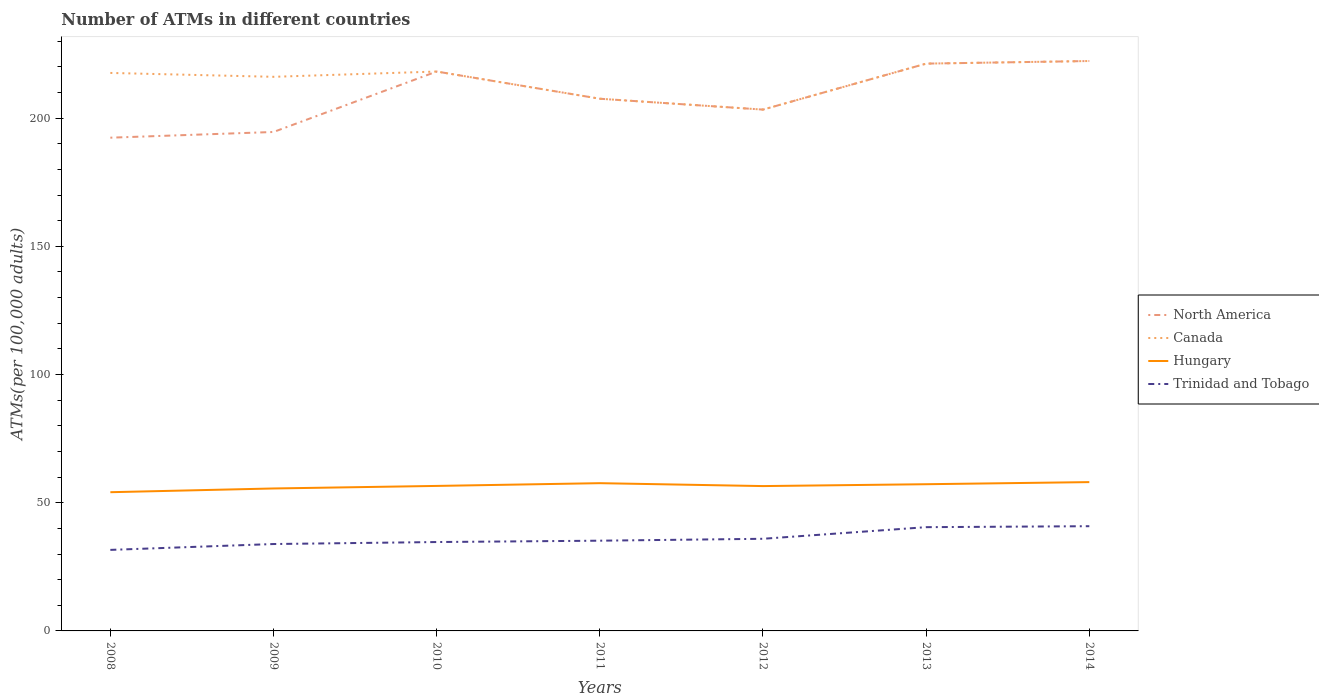How many different coloured lines are there?
Offer a terse response. 4. Across all years, what is the maximum number of ATMs in Trinidad and Tobago?
Make the answer very short. 31.6. What is the total number of ATMs in Hungary in the graph?
Your answer should be compact. 0.06. What is the difference between the highest and the second highest number of ATMs in Trinidad and Tobago?
Your answer should be very brief. 9.24. How many years are there in the graph?
Provide a succinct answer. 7. Does the graph contain any zero values?
Provide a succinct answer. No. Does the graph contain grids?
Give a very brief answer. No. How many legend labels are there?
Your answer should be very brief. 4. How are the legend labels stacked?
Your response must be concise. Vertical. What is the title of the graph?
Offer a terse response. Number of ATMs in different countries. What is the label or title of the Y-axis?
Your answer should be very brief. ATMs(per 100,0 adults). What is the ATMs(per 100,000 adults) in North America in 2008?
Provide a short and direct response. 192.37. What is the ATMs(per 100,000 adults) of Canada in 2008?
Ensure brevity in your answer.  217.63. What is the ATMs(per 100,000 adults) in Hungary in 2008?
Keep it short and to the point. 54.1. What is the ATMs(per 100,000 adults) in Trinidad and Tobago in 2008?
Make the answer very short. 31.6. What is the ATMs(per 100,000 adults) in North America in 2009?
Your response must be concise. 194.6. What is the ATMs(per 100,000 adults) of Canada in 2009?
Ensure brevity in your answer.  216.11. What is the ATMs(per 100,000 adults) of Hungary in 2009?
Give a very brief answer. 55.56. What is the ATMs(per 100,000 adults) in Trinidad and Tobago in 2009?
Provide a succinct answer. 33.89. What is the ATMs(per 100,000 adults) of North America in 2010?
Keep it short and to the point. 218.18. What is the ATMs(per 100,000 adults) of Canada in 2010?
Offer a terse response. 218.18. What is the ATMs(per 100,000 adults) of Hungary in 2010?
Give a very brief answer. 56.55. What is the ATMs(per 100,000 adults) in Trinidad and Tobago in 2010?
Offer a terse response. 34.67. What is the ATMs(per 100,000 adults) in North America in 2011?
Offer a very short reply. 207.56. What is the ATMs(per 100,000 adults) in Canada in 2011?
Ensure brevity in your answer.  207.56. What is the ATMs(per 100,000 adults) of Hungary in 2011?
Offer a terse response. 57.63. What is the ATMs(per 100,000 adults) of Trinidad and Tobago in 2011?
Offer a very short reply. 35.19. What is the ATMs(per 100,000 adults) in North America in 2012?
Provide a short and direct response. 203.33. What is the ATMs(per 100,000 adults) in Canada in 2012?
Your answer should be very brief. 203.33. What is the ATMs(per 100,000 adults) in Hungary in 2012?
Ensure brevity in your answer.  56.49. What is the ATMs(per 100,000 adults) of Trinidad and Tobago in 2012?
Your answer should be compact. 35.94. What is the ATMs(per 100,000 adults) in North America in 2013?
Provide a succinct answer. 221.26. What is the ATMs(per 100,000 adults) of Canada in 2013?
Offer a terse response. 221.26. What is the ATMs(per 100,000 adults) in Hungary in 2013?
Ensure brevity in your answer.  57.22. What is the ATMs(per 100,000 adults) of Trinidad and Tobago in 2013?
Your answer should be compact. 40.47. What is the ATMs(per 100,000 adults) of North America in 2014?
Provide a succinct answer. 222.27. What is the ATMs(per 100,000 adults) in Canada in 2014?
Give a very brief answer. 222.27. What is the ATMs(per 100,000 adults) in Hungary in 2014?
Your response must be concise. 58.04. What is the ATMs(per 100,000 adults) in Trinidad and Tobago in 2014?
Your answer should be compact. 40.84. Across all years, what is the maximum ATMs(per 100,000 adults) of North America?
Your response must be concise. 222.27. Across all years, what is the maximum ATMs(per 100,000 adults) of Canada?
Make the answer very short. 222.27. Across all years, what is the maximum ATMs(per 100,000 adults) of Hungary?
Your answer should be compact. 58.04. Across all years, what is the maximum ATMs(per 100,000 adults) in Trinidad and Tobago?
Provide a succinct answer. 40.84. Across all years, what is the minimum ATMs(per 100,000 adults) of North America?
Your response must be concise. 192.37. Across all years, what is the minimum ATMs(per 100,000 adults) of Canada?
Provide a succinct answer. 203.33. Across all years, what is the minimum ATMs(per 100,000 adults) in Hungary?
Provide a succinct answer. 54.1. Across all years, what is the minimum ATMs(per 100,000 adults) of Trinidad and Tobago?
Offer a terse response. 31.6. What is the total ATMs(per 100,000 adults) in North America in the graph?
Your answer should be compact. 1459.57. What is the total ATMs(per 100,000 adults) in Canada in the graph?
Ensure brevity in your answer.  1506.34. What is the total ATMs(per 100,000 adults) in Hungary in the graph?
Make the answer very short. 395.59. What is the total ATMs(per 100,000 adults) in Trinidad and Tobago in the graph?
Provide a short and direct response. 252.6. What is the difference between the ATMs(per 100,000 adults) of North America in 2008 and that in 2009?
Make the answer very short. -2.23. What is the difference between the ATMs(per 100,000 adults) in Canada in 2008 and that in 2009?
Ensure brevity in your answer.  1.51. What is the difference between the ATMs(per 100,000 adults) of Hungary in 2008 and that in 2009?
Keep it short and to the point. -1.46. What is the difference between the ATMs(per 100,000 adults) of Trinidad and Tobago in 2008 and that in 2009?
Your response must be concise. -2.29. What is the difference between the ATMs(per 100,000 adults) in North America in 2008 and that in 2010?
Your response must be concise. -25.8. What is the difference between the ATMs(per 100,000 adults) in Canada in 2008 and that in 2010?
Give a very brief answer. -0.55. What is the difference between the ATMs(per 100,000 adults) in Hungary in 2008 and that in 2010?
Ensure brevity in your answer.  -2.45. What is the difference between the ATMs(per 100,000 adults) of Trinidad and Tobago in 2008 and that in 2010?
Your response must be concise. -3.06. What is the difference between the ATMs(per 100,000 adults) in North America in 2008 and that in 2011?
Ensure brevity in your answer.  -15.19. What is the difference between the ATMs(per 100,000 adults) of Canada in 2008 and that in 2011?
Your response must be concise. 10.06. What is the difference between the ATMs(per 100,000 adults) in Hungary in 2008 and that in 2011?
Keep it short and to the point. -3.52. What is the difference between the ATMs(per 100,000 adults) in Trinidad and Tobago in 2008 and that in 2011?
Give a very brief answer. -3.59. What is the difference between the ATMs(per 100,000 adults) in North America in 2008 and that in 2012?
Provide a short and direct response. -10.95. What is the difference between the ATMs(per 100,000 adults) of Canada in 2008 and that in 2012?
Your answer should be very brief. 14.3. What is the difference between the ATMs(per 100,000 adults) in Hungary in 2008 and that in 2012?
Keep it short and to the point. -2.39. What is the difference between the ATMs(per 100,000 adults) of Trinidad and Tobago in 2008 and that in 2012?
Provide a succinct answer. -4.33. What is the difference between the ATMs(per 100,000 adults) in North America in 2008 and that in 2013?
Ensure brevity in your answer.  -28.89. What is the difference between the ATMs(per 100,000 adults) in Canada in 2008 and that in 2013?
Your answer should be very brief. -3.63. What is the difference between the ATMs(per 100,000 adults) of Hungary in 2008 and that in 2013?
Your response must be concise. -3.11. What is the difference between the ATMs(per 100,000 adults) in Trinidad and Tobago in 2008 and that in 2013?
Offer a terse response. -8.86. What is the difference between the ATMs(per 100,000 adults) of North America in 2008 and that in 2014?
Offer a terse response. -29.9. What is the difference between the ATMs(per 100,000 adults) in Canada in 2008 and that in 2014?
Keep it short and to the point. -4.65. What is the difference between the ATMs(per 100,000 adults) in Hungary in 2008 and that in 2014?
Give a very brief answer. -3.93. What is the difference between the ATMs(per 100,000 adults) in Trinidad and Tobago in 2008 and that in 2014?
Keep it short and to the point. -9.24. What is the difference between the ATMs(per 100,000 adults) in North America in 2009 and that in 2010?
Your response must be concise. -23.58. What is the difference between the ATMs(per 100,000 adults) of Canada in 2009 and that in 2010?
Your answer should be very brief. -2.06. What is the difference between the ATMs(per 100,000 adults) of Hungary in 2009 and that in 2010?
Give a very brief answer. -0.99. What is the difference between the ATMs(per 100,000 adults) in Trinidad and Tobago in 2009 and that in 2010?
Keep it short and to the point. -0.78. What is the difference between the ATMs(per 100,000 adults) in North America in 2009 and that in 2011?
Your response must be concise. -12.96. What is the difference between the ATMs(per 100,000 adults) in Canada in 2009 and that in 2011?
Provide a succinct answer. 8.55. What is the difference between the ATMs(per 100,000 adults) in Hungary in 2009 and that in 2011?
Give a very brief answer. -2.07. What is the difference between the ATMs(per 100,000 adults) of Trinidad and Tobago in 2009 and that in 2011?
Ensure brevity in your answer.  -1.3. What is the difference between the ATMs(per 100,000 adults) in North America in 2009 and that in 2012?
Provide a succinct answer. -8.73. What is the difference between the ATMs(per 100,000 adults) in Canada in 2009 and that in 2012?
Your response must be concise. 12.79. What is the difference between the ATMs(per 100,000 adults) in Hungary in 2009 and that in 2012?
Offer a terse response. -0.93. What is the difference between the ATMs(per 100,000 adults) of Trinidad and Tobago in 2009 and that in 2012?
Ensure brevity in your answer.  -2.05. What is the difference between the ATMs(per 100,000 adults) of North America in 2009 and that in 2013?
Your answer should be compact. -26.66. What is the difference between the ATMs(per 100,000 adults) of Canada in 2009 and that in 2013?
Your answer should be compact. -5.15. What is the difference between the ATMs(per 100,000 adults) of Hungary in 2009 and that in 2013?
Keep it short and to the point. -1.66. What is the difference between the ATMs(per 100,000 adults) in Trinidad and Tobago in 2009 and that in 2013?
Provide a short and direct response. -6.58. What is the difference between the ATMs(per 100,000 adults) of North America in 2009 and that in 2014?
Keep it short and to the point. -27.68. What is the difference between the ATMs(per 100,000 adults) of Canada in 2009 and that in 2014?
Ensure brevity in your answer.  -6.16. What is the difference between the ATMs(per 100,000 adults) of Hungary in 2009 and that in 2014?
Your answer should be very brief. -2.48. What is the difference between the ATMs(per 100,000 adults) in Trinidad and Tobago in 2009 and that in 2014?
Offer a very short reply. -6.95. What is the difference between the ATMs(per 100,000 adults) in North America in 2010 and that in 2011?
Your answer should be compact. 10.61. What is the difference between the ATMs(per 100,000 adults) in Canada in 2010 and that in 2011?
Your response must be concise. 10.61. What is the difference between the ATMs(per 100,000 adults) of Hungary in 2010 and that in 2011?
Your response must be concise. -1.08. What is the difference between the ATMs(per 100,000 adults) in Trinidad and Tobago in 2010 and that in 2011?
Keep it short and to the point. -0.52. What is the difference between the ATMs(per 100,000 adults) in North America in 2010 and that in 2012?
Offer a very short reply. 14.85. What is the difference between the ATMs(per 100,000 adults) in Canada in 2010 and that in 2012?
Provide a succinct answer. 14.85. What is the difference between the ATMs(per 100,000 adults) of Hungary in 2010 and that in 2012?
Your answer should be compact. 0.06. What is the difference between the ATMs(per 100,000 adults) in Trinidad and Tobago in 2010 and that in 2012?
Provide a succinct answer. -1.27. What is the difference between the ATMs(per 100,000 adults) of North America in 2010 and that in 2013?
Your response must be concise. -3.08. What is the difference between the ATMs(per 100,000 adults) in Canada in 2010 and that in 2013?
Offer a very short reply. -3.08. What is the difference between the ATMs(per 100,000 adults) of Hungary in 2010 and that in 2013?
Provide a succinct answer. -0.67. What is the difference between the ATMs(per 100,000 adults) of Trinidad and Tobago in 2010 and that in 2013?
Your answer should be very brief. -5.8. What is the difference between the ATMs(per 100,000 adults) in North America in 2010 and that in 2014?
Make the answer very short. -4.1. What is the difference between the ATMs(per 100,000 adults) of Canada in 2010 and that in 2014?
Give a very brief answer. -4.1. What is the difference between the ATMs(per 100,000 adults) of Hungary in 2010 and that in 2014?
Provide a succinct answer. -1.49. What is the difference between the ATMs(per 100,000 adults) of Trinidad and Tobago in 2010 and that in 2014?
Provide a succinct answer. -6.18. What is the difference between the ATMs(per 100,000 adults) of North America in 2011 and that in 2012?
Your response must be concise. 4.24. What is the difference between the ATMs(per 100,000 adults) in Canada in 2011 and that in 2012?
Offer a very short reply. 4.24. What is the difference between the ATMs(per 100,000 adults) in Hungary in 2011 and that in 2012?
Provide a succinct answer. 1.13. What is the difference between the ATMs(per 100,000 adults) of Trinidad and Tobago in 2011 and that in 2012?
Your response must be concise. -0.75. What is the difference between the ATMs(per 100,000 adults) of North America in 2011 and that in 2013?
Offer a terse response. -13.7. What is the difference between the ATMs(per 100,000 adults) of Canada in 2011 and that in 2013?
Make the answer very short. -13.7. What is the difference between the ATMs(per 100,000 adults) in Hungary in 2011 and that in 2013?
Your response must be concise. 0.41. What is the difference between the ATMs(per 100,000 adults) of Trinidad and Tobago in 2011 and that in 2013?
Provide a succinct answer. -5.28. What is the difference between the ATMs(per 100,000 adults) in North America in 2011 and that in 2014?
Your answer should be very brief. -14.71. What is the difference between the ATMs(per 100,000 adults) of Canada in 2011 and that in 2014?
Ensure brevity in your answer.  -14.71. What is the difference between the ATMs(per 100,000 adults) in Hungary in 2011 and that in 2014?
Offer a very short reply. -0.41. What is the difference between the ATMs(per 100,000 adults) in Trinidad and Tobago in 2011 and that in 2014?
Ensure brevity in your answer.  -5.65. What is the difference between the ATMs(per 100,000 adults) of North America in 2012 and that in 2013?
Offer a very short reply. -17.93. What is the difference between the ATMs(per 100,000 adults) of Canada in 2012 and that in 2013?
Give a very brief answer. -17.93. What is the difference between the ATMs(per 100,000 adults) of Hungary in 2012 and that in 2013?
Your response must be concise. -0.72. What is the difference between the ATMs(per 100,000 adults) in Trinidad and Tobago in 2012 and that in 2013?
Provide a short and direct response. -4.53. What is the difference between the ATMs(per 100,000 adults) of North America in 2012 and that in 2014?
Keep it short and to the point. -18.95. What is the difference between the ATMs(per 100,000 adults) of Canada in 2012 and that in 2014?
Provide a succinct answer. -18.95. What is the difference between the ATMs(per 100,000 adults) of Hungary in 2012 and that in 2014?
Provide a short and direct response. -1.54. What is the difference between the ATMs(per 100,000 adults) in Trinidad and Tobago in 2012 and that in 2014?
Provide a succinct answer. -4.91. What is the difference between the ATMs(per 100,000 adults) in North America in 2013 and that in 2014?
Your response must be concise. -1.01. What is the difference between the ATMs(per 100,000 adults) of Canada in 2013 and that in 2014?
Your answer should be compact. -1.01. What is the difference between the ATMs(per 100,000 adults) of Hungary in 2013 and that in 2014?
Give a very brief answer. -0.82. What is the difference between the ATMs(per 100,000 adults) in Trinidad and Tobago in 2013 and that in 2014?
Keep it short and to the point. -0.38. What is the difference between the ATMs(per 100,000 adults) of North America in 2008 and the ATMs(per 100,000 adults) of Canada in 2009?
Give a very brief answer. -23.74. What is the difference between the ATMs(per 100,000 adults) of North America in 2008 and the ATMs(per 100,000 adults) of Hungary in 2009?
Offer a terse response. 136.81. What is the difference between the ATMs(per 100,000 adults) in North America in 2008 and the ATMs(per 100,000 adults) in Trinidad and Tobago in 2009?
Provide a short and direct response. 158.48. What is the difference between the ATMs(per 100,000 adults) in Canada in 2008 and the ATMs(per 100,000 adults) in Hungary in 2009?
Make the answer very short. 162.07. What is the difference between the ATMs(per 100,000 adults) of Canada in 2008 and the ATMs(per 100,000 adults) of Trinidad and Tobago in 2009?
Provide a succinct answer. 183.74. What is the difference between the ATMs(per 100,000 adults) of Hungary in 2008 and the ATMs(per 100,000 adults) of Trinidad and Tobago in 2009?
Offer a terse response. 20.21. What is the difference between the ATMs(per 100,000 adults) in North America in 2008 and the ATMs(per 100,000 adults) in Canada in 2010?
Your answer should be compact. -25.8. What is the difference between the ATMs(per 100,000 adults) of North America in 2008 and the ATMs(per 100,000 adults) of Hungary in 2010?
Provide a succinct answer. 135.82. What is the difference between the ATMs(per 100,000 adults) of North America in 2008 and the ATMs(per 100,000 adults) of Trinidad and Tobago in 2010?
Provide a succinct answer. 157.71. What is the difference between the ATMs(per 100,000 adults) in Canada in 2008 and the ATMs(per 100,000 adults) in Hungary in 2010?
Provide a succinct answer. 161.08. What is the difference between the ATMs(per 100,000 adults) in Canada in 2008 and the ATMs(per 100,000 adults) in Trinidad and Tobago in 2010?
Your answer should be very brief. 182.96. What is the difference between the ATMs(per 100,000 adults) in Hungary in 2008 and the ATMs(per 100,000 adults) in Trinidad and Tobago in 2010?
Offer a very short reply. 19.44. What is the difference between the ATMs(per 100,000 adults) in North America in 2008 and the ATMs(per 100,000 adults) in Canada in 2011?
Your response must be concise. -15.19. What is the difference between the ATMs(per 100,000 adults) of North America in 2008 and the ATMs(per 100,000 adults) of Hungary in 2011?
Provide a succinct answer. 134.75. What is the difference between the ATMs(per 100,000 adults) of North America in 2008 and the ATMs(per 100,000 adults) of Trinidad and Tobago in 2011?
Offer a very short reply. 157.18. What is the difference between the ATMs(per 100,000 adults) in Canada in 2008 and the ATMs(per 100,000 adults) in Hungary in 2011?
Give a very brief answer. 160. What is the difference between the ATMs(per 100,000 adults) in Canada in 2008 and the ATMs(per 100,000 adults) in Trinidad and Tobago in 2011?
Ensure brevity in your answer.  182.44. What is the difference between the ATMs(per 100,000 adults) of Hungary in 2008 and the ATMs(per 100,000 adults) of Trinidad and Tobago in 2011?
Make the answer very short. 18.91. What is the difference between the ATMs(per 100,000 adults) of North America in 2008 and the ATMs(per 100,000 adults) of Canada in 2012?
Your response must be concise. -10.95. What is the difference between the ATMs(per 100,000 adults) of North America in 2008 and the ATMs(per 100,000 adults) of Hungary in 2012?
Your response must be concise. 135.88. What is the difference between the ATMs(per 100,000 adults) in North America in 2008 and the ATMs(per 100,000 adults) in Trinidad and Tobago in 2012?
Make the answer very short. 156.44. What is the difference between the ATMs(per 100,000 adults) of Canada in 2008 and the ATMs(per 100,000 adults) of Hungary in 2012?
Your response must be concise. 161.13. What is the difference between the ATMs(per 100,000 adults) of Canada in 2008 and the ATMs(per 100,000 adults) of Trinidad and Tobago in 2012?
Offer a very short reply. 181.69. What is the difference between the ATMs(per 100,000 adults) in Hungary in 2008 and the ATMs(per 100,000 adults) in Trinidad and Tobago in 2012?
Provide a short and direct response. 18.17. What is the difference between the ATMs(per 100,000 adults) of North America in 2008 and the ATMs(per 100,000 adults) of Canada in 2013?
Offer a terse response. -28.89. What is the difference between the ATMs(per 100,000 adults) of North America in 2008 and the ATMs(per 100,000 adults) of Hungary in 2013?
Your answer should be compact. 135.16. What is the difference between the ATMs(per 100,000 adults) of North America in 2008 and the ATMs(per 100,000 adults) of Trinidad and Tobago in 2013?
Make the answer very short. 151.91. What is the difference between the ATMs(per 100,000 adults) in Canada in 2008 and the ATMs(per 100,000 adults) in Hungary in 2013?
Give a very brief answer. 160.41. What is the difference between the ATMs(per 100,000 adults) of Canada in 2008 and the ATMs(per 100,000 adults) of Trinidad and Tobago in 2013?
Your response must be concise. 177.16. What is the difference between the ATMs(per 100,000 adults) in Hungary in 2008 and the ATMs(per 100,000 adults) in Trinidad and Tobago in 2013?
Make the answer very short. 13.64. What is the difference between the ATMs(per 100,000 adults) in North America in 2008 and the ATMs(per 100,000 adults) in Canada in 2014?
Your response must be concise. -29.9. What is the difference between the ATMs(per 100,000 adults) of North America in 2008 and the ATMs(per 100,000 adults) of Hungary in 2014?
Your answer should be very brief. 134.33. What is the difference between the ATMs(per 100,000 adults) of North America in 2008 and the ATMs(per 100,000 adults) of Trinidad and Tobago in 2014?
Offer a very short reply. 151.53. What is the difference between the ATMs(per 100,000 adults) in Canada in 2008 and the ATMs(per 100,000 adults) in Hungary in 2014?
Keep it short and to the point. 159.59. What is the difference between the ATMs(per 100,000 adults) of Canada in 2008 and the ATMs(per 100,000 adults) of Trinidad and Tobago in 2014?
Your answer should be compact. 176.78. What is the difference between the ATMs(per 100,000 adults) of Hungary in 2008 and the ATMs(per 100,000 adults) of Trinidad and Tobago in 2014?
Offer a very short reply. 13.26. What is the difference between the ATMs(per 100,000 adults) in North America in 2009 and the ATMs(per 100,000 adults) in Canada in 2010?
Offer a terse response. -23.58. What is the difference between the ATMs(per 100,000 adults) of North America in 2009 and the ATMs(per 100,000 adults) of Hungary in 2010?
Your answer should be very brief. 138.05. What is the difference between the ATMs(per 100,000 adults) in North America in 2009 and the ATMs(per 100,000 adults) in Trinidad and Tobago in 2010?
Keep it short and to the point. 159.93. What is the difference between the ATMs(per 100,000 adults) of Canada in 2009 and the ATMs(per 100,000 adults) of Hungary in 2010?
Provide a short and direct response. 159.56. What is the difference between the ATMs(per 100,000 adults) in Canada in 2009 and the ATMs(per 100,000 adults) in Trinidad and Tobago in 2010?
Your response must be concise. 181.45. What is the difference between the ATMs(per 100,000 adults) in Hungary in 2009 and the ATMs(per 100,000 adults) in Trinidad and Tobago in 2010?
Provide a succinct answer. 20.89. What is the difference between the ATMs(per 100,000 adults) in North America in 2009 and the ATMs(per 100,000 adults) in Canada in 2011?
Provide a succinct answer. -12.96. What is the difference between the ATMs(per 100,000 adults) in North America in 2009 and the ATMs(per 100,000 adults) in Hungary in 2011?
Your response must be concise. 136.97. What is the difference between the ATMs(per 100,000 adults) of North America in 2009 and the ATMs(per 100,000 adults) of Trinidad and Tobago in 2011?
Keep it short and to the point. 159.41. What is the difference between the ATMs(per 100,000 adults) of Canada in 2009 and the ATMs(per 100,000 adults) of Hungary in 2011?
Provide a short and direct response. 158.49. What is the difference between the ATMs(per 100,000 adults) of Canada in 2009 and the ATMs(per 100,000 adults) of Trinidad and Tobago in 2011?
Your response must be concise. 180.92. What is the difference between the ATMs(per 100,000 adults) in Hungary in 2009 and the ATMs(per 100,000 adults) in Trinidad and Tobago in 2011?
Your answer should be very brief. 20.37. What is the difference between the ATMs(per 100,000 adults) of North America in 2009 and the ATMs(per 100,000 adults) of Canada in 2012?
Your answer should be very brief. -8.73. What is the difference between the ATMs(per 100,000 adults) in North America in 2009 and the ATMs(per 100,000 adults) in Hungary in 2012?
Make the answer very short. 138.1. What is the difference between the ATMs(per 100,000 adults) in North America in 2009 and the ATMs(per 100,000 adults) in Trinidad and Tobago in 2012?
Make the answer very short. 158.66. What is the difference between the ATMs(per 100,000 adults) of Canada in 2009 and the ATMs(per 100,000 adults) of Hungary in 2012?
Give a very brief answer. 159.62. What is the difference between the ATMs(per 100,000 adults) in Canada in 2009 and the ATMs(per 100,000 adults) in Trinidad and Tobago in 2012?
Offer a very short reply. 180.18. What is the difference between the ATMs(per 100,000 adults) of Hungary in 2009 and the ATMs(per 100,000 adults) of Trinidad and Tobago in 2012?
Offer a terse response. 19.62. What is the difference between the ATMs(per 100,000 adults) in North America in 2009 and the ATMs(per 100,000 adults) in Canada in 2013?
Make the answer very short. -26.66. What is the difference between the ATMs(per 100,000 adults) in North America in 2009 and the ATMs(per 100,000 adults) in Hungary in 2013?
Keep it short and to the point. 137.38. What is the difference between the ATMs(per 100,000 adults) of North America in 2009 and the ATMs(per 100,000 adults) of Trinidad and Tobago in 2013?
Keep it short and to the point. 154.13. What is the difference between the ATMs(per 100,000 adults) in Canada in 2009 and the ATMs(per 100,000 adults) in Hungary in 2013?
Ensure brevity in your answer.  158.9. What is the difference between the ATMs(per 100,000 adults) of Canada in 2009 and the ATMs(per 100,000 adults) of Trinidad and Tobago in 2013?
Ensure brevity in your answer.  175.65. What is the difference between the ATMs(per 100,000 adults) in Hungary in 2009 and the ATMs(per 100,000 adults) in Trinidad and Tobago in 2013?
Provide a succinct answer. 15.09. What is the difference between the ATMs(per 100,000 adults) of North America in 2009 and the ATMs(per 100,000 adults) of Canada in 2014?
Ensure brevity in your answer.  -27.68. What is the difference between the ATMs(per 100,000 adults) of North America in 2009 and the ATMs(per 100,000 adults) of Hungary in 2014?
Ensure brevity in your answer.  136.56. What is the difference between the ATMs(per 100,000 adults) of North America in 2009 and the ATMs(per 100,000 adults) of Trinidad and Tobago in 2014?
Give a very brief answer. 153.76. What is the difference between the ATMs(per 100,000 adults) of Canada in 2009 and the ATMs(per 100,000 adults) of Hungary in 2014?
Give a very brief answer. 158.08. What is the difference between the ATMs(per 100,000 adults) in Canada in 2009 and the ATMs(per 100,000 adults) in Trinidad and Tobago in 2014?
Offer a terse response. 175.27. What is the difference between the ATMs(per 100,000 adults) of Hungary in 2009 and the ATMs(per 100,000 adults) of Trinidad and Tobago in 2014?
Keep it short and to the point. 14.72. What is the difference between the ATMs(per 100,000 adults) of North America in 2010 and the ATMs(per 100,000 adults) of Canada in 2011?
Provide a succinct answer. 10.61. What is the difference between the ATMs(per 100,000 adults) of North America in 2010 and the ATMs(per 100,000 adults) of Hungary in 2011?
Provide a succinct answer. 160.55. What is the difference between the ATMs(per 100,000 adults) in North America in 2010 and the ATMs(per 100,000 adults) in Trinidad and Tobago in 2011?
Provide a short and direct response. 182.99. What is the difference between the ATMs(per 100,000 adults) of Canada in 2010 and the ATMs(per 100,000 adults) of Hungary in 2011?
Give a very brief answer. 160.55. What is the difference between the ATMs(per 100,000 adults) of Canada in 2010 and the ATMs(per 100,000 adults) of Trinidad and Tobago in 2011?
Your response must be concise. 182.99. What is the difference between the ATMs(per 100,000 adults) of Hungary in 2010 and the ATMs(per 100,000 adults) of Trinidad and Tobago in 2011?
Keep it short and to the point. 21.36. What is the difference between the ATMs(per 100,000 adults) in North America in 2010 and the ATMs(per 100,000 adults) in Canada in 2012?
Keep it short and to the point. 14.85. What is the difference between the ATMs(per 100,000 adults) in North America in 2010 and the ATMs(per 100,000 adults) in Hungary in 2012?
Make the answer very short. 161.68. What is the difference between the ATMs(per 100,000 adults) in North America in 2010 and the ATMs(per 100,000 adults) in Trinidad and Tobago in 2012?
Keep it short and to the point. 182.24. What is the difference between the ATMs(per 100,000 adults) in Canada in 2010 and the ATMs(per 100,000 adults) in Hungary in 2012?
Provide a succinct answer. 161.68. What is the difference between the ATMs(per 100,000 adults) of Canada in 2010 and the ATMs(per 100,000 adults) of Trinidad and Tobago in 2012?
Offer a very short reply. 182.24. What is the difference between the ATMs(per 100,000 adults) in Hungary in 2010 and the ATMs(per 100,000 adults) in Trinidad and Tobago in 2012?
Make the answer very short. 20.61. What is the difference between the ATMs(per 100,000 adults) in North America in 2010 and the ATMs(per 100,000 adults) in Canada in 2013?
Keep it short and to the point. -3.08. What is the difference between the ATMs(per 100,000 adults) in North America in 2010 and the ATMs(per 100,000 adults) in Hungary in 2013?
Your answer should be very brief. 160.96. What is the difference between the ATMs(per 100,000 adults) of North America in 2010 and the ATMs(per 100,000 adults) of Trinidad and Tobago in 2013?
Provide a succinct answer. 177.71. What is the difference between the ATMs(per 100,000 adults) of Canada in 2010 and the ATMs(per 100,000 adults) of Hungary in 2013?
Ensure brevity in your answer.  160.96. What is the difference between the ATMs(per 100,000 adults) of Canada in 2010 and the ATMs(per 100,000 adults) of Trinidad and Tobago in 2013?
Give a very brief answer. 177.71. What is the difference between the ATMs(per 100,000 adults) in Hungary in 2010 and the ATMs(per 100,000 adults) in Trinidad and Tobago in 2013?
Ensure brevity in your answer.  16.08. What is the difference between the ATMs(per 100,000 adults) in North America in 2010 and the ATMs(per 100,000 adults) in Canada in 2014?
Offer a very short reply. -4.1. What is the difference between the ATMs(per 100,000 adults) of North America in 2010 and the ATMs(per 100,000 adults) of Hungary in 2014?
Provide a succinct answer. 160.14. What is the difference between the ATMs(per 100,000 adults) in North America in 2010 and the ATMs(per 100,000 adults) in Trinidad and Tobago in 2014?
Your answer should be very brief. 177.33. What is the difference between the ATMs(per 100,000 adults) in Canada in 2010 and the ATMs(per 100,000 adults) in Hungary in 2014?
Your response must be concise. 160.14. What is the difference between the ATMs(per 100,000 adults) of Canada in 2010 and the ATMs(per 100,000 adults) of Trinidad and Tobago in 2014?
Make the answer very short. 177.33. What is the difference between the ATMs(per 100,000 adults) of Hungary in 2010 and the ATMs(per 100,000 adults) of Trinidad and Tobago in 2014?
Offer a terse response. 15.71. What is the difference between the ATMs(per 100,000 adults) in North America in 2011 and the ATMs(per 100,000 adults) in Canada in 2012?
Offer a terse response. 4.24. What is the difference between the ATMs(per 100,000 adults) of North America in 2011 and the ATMs(per 100,000 adults) of Hungary in 2012?
Provide a succinct answer. 151.07. What is the difference between the ATMs(per 100,000 adults) of North America in 2011 and the ATMs(per 100,000 adults) of Trinidad and Tobago in 2012?
Provide a succinct answer. 171.63. What is the difference between the ATMs(per 100,000 adults) of Canada in 2011 and the ATMs(per 100,000 adults) of Hungary in 2012?
Give a very brief answer. 151.07. What is the difference between the ATMs(per 100,000 adults) of Canada in 2011 and the ATMs(per 100,000 adults) of Trinidad and Tobago in 2012?
Provide a succinct answer. 171.63. What is the difference between the ATMs(per 100,000 adults) in Hungary in 2011 and the ATMs(per 100,000 adults) in Trinidad and Tobago in 2012?
Your answer should be very brief. 21.69. What is the difference between the ATMs(per 100,000 adults) of North America in 2011 and the ATMs(per 100,000 adults) of Canada in 2013?
Keep it short and to the point. -13.7. What is the difference between the ATMs(per 100,000 adults) of North America in 2011 and the ATMs(per 100,000 adults) of Hungary in 2013?
Make the answer very short. 150.35. What is the difference between the ATMs(per 100,000 adults) of North America in 2011 and the ATMs(per 100,000 adults) of Trinidad and Tobago in 2013?
Provide a short and direct response. 167.1. What is the difference between the ATMs(per 100,000 adults) of Canada in 2011 and the ATMs(per 100,000 adults) of Hungary in 2013?
Your response must be concise. 150.35. What is the difference between the ATMs(per 100,000 adults) of Canada in 2011 and the ATMs(per 100,000 adults) of Trinidad and Tobago in 2013?
Provide a succinct answer. 167.1. What is the difference between the ATMs(per 100,000 adults) in Hungary in 2011 and the ATMs(per 100,000 adults) in Trinidad and Tobago in 2013?
Your answer should be compact. 17.16. What is the difference between the ATMs(per 100,000 adults) in North America in 2011 and the ATMs(per 100,000 adults) in Canada in 2014?
Make the answer very short. -14.71. What is the difference between the ATMs(per 100,000 adults) in North America in 2011 and the ATMs(per 100,000 adults) in Hungary in 2014?
Provide a succinct answer. 149.52. What is the difference between the ATMs(per 100,000 adults) of North America in 2011 and the ATMs(per 100,000 adults) of Trinidad and Tobago in 2014?
Your answer should be very brief. 166.72. What is the difference between the ATMs(per 100,000 adults) in Canada in 2011 and the ATMs(per 100,000 adults) in Hungary in 2014?
Offer a terse response. 149.52. What is the difference between the ATMs(per 100,000 adults) in Canada in 2011 and the ATMs(per 100,000 adults) in Trinidad and Tobago in 2014?
Ensure brevity in your answer.  166.72. What is the difference between the ATMs(per 100,000 adults) of Hungary in 2011 and the ATMs(per 100,000 adults) of Trinidad and Tobago in 2014?
Offer a very short reply. 16.78. What is the difference between the ATMs(per 100,000 adults) of North America in 2012 and the ATMs(per 100,000 adults) of Canada in 2013?
Ensure brevity in your answer.  -17.93. What is the difference between the ATMs(per 100,000 adults) in North America in 2012 and the ATMs(per 100,000 adults) in Hungary in 2013?
Keep it short and to the point. 146.11. What is the difference between the ATMs(per 100,000 adults) of North America in 2012 and the ATMs(per 100,000 adults) of Trinidad and Tobago in 2013?
Keep it short and to the point. 162.86. What is the difference between the ATMs(per 100,000 adults) in Canada in 2012 and the ATMs(per 100,000 adults) in Hungary in 2013?
Your answer should be very brief. 146.11. What is the difference between the ATMs(per 100,000 adults) of Canada in 2012 and the ATMs(per 100,000 adults) of Trinidad and Tobago in 2013?
Provide a succinct answer. 162.86. What is the difference between the ATMs(per 100,000 adults) of Hungary in 2012 and the ATMs(per 100,000 adults) of Trinidad and Tobago in 2013?
Your response must be concise. 16.03. What is the difference between the ATMs(per 100,000 adults) in North America in 2012 and the ATMs(per 100,000 adults) in Canada in 2014?
Offer a terse response. -18.95. What is the difference between the ATMs(per 100,000 adults) in North America in 2012 and the ATMs(per 100,000 adults) in Hungary in 2014?
Your response must be concise. 145.29. What is the difference between the ATMs(per 100,000 adults) of North America in 2012 and the ATMs(per 100,000 adults) of Trinidad and Tobago in 2014?
Provide a short and direct response. 162.48. What is the difference between the ATMs(per 100,000 adults) of Canada in 2012 and the ATMs(per 100,000 adults) of Hungary in 2014?
Your response must be concise. 145.29. What is the difference between the ATMs(per 100,000 adults) of Canada in 2012 and the ATMs(per 100,000 adults) of Trinidad and Tobago in 2014?
Your answer should be very brief. 162.48. What is the difference between the ATMs(per 100,000 adults) of Hungary in 2012 and the ATMs(per 100,000 adults) of Trinidad and Tobago in 2014?
Ensure brevity in your answer.  15.65. What is the difference between the ATMs(per 100,000 adults) in North America in 2013 and the ATMs(per 100,000 adults) in Canada in 2014?
Ensure brevity in your answer.  -1.01. What is the difference between the ATMs(per 100,000 adults) of North America in 2013 and the ATMs(per 100,000 adults) of Hungary in 2014?
Keep it short and to the point. 163.22. What is the difference between the ATMs(per 100,000 adults) of North America in 2013 and the ATMs(per 100,000 adults) of Trinidad and Tobago in 2014?
Give a very brief answer. 180.42. What is the difference between the ATMs(per 100,000 adults) of Canada in 2013 and the ATMs(per 100,000 adults) of Hungary in 2014?
Give a very brief answer. 163.22. What is the difference between the ATMs(per 100,000 adults) of Canada in 2013 and the ATMs(per 100,000 adults) of Trinidad and Tobago in 2014?
Ensure brevity in your answer.  180.42. What is the difference between the ATMs(per 100,000 adults) of Hungary in 2013 and the ATMs(per 100,000 adults) of Trinidad and Tobago in 2014?
Your response must be concise. 16.37. What is the average ATMs(per 100,000 adults) of North America per year?
Your response must be concise. 208.51. What is the average ATMs(per 100,000 adults) in Canada per year?
Make the answer very short. 215.19. What is the average ATMs(per 100,000 adults) in Hungary per year?
Provide a short and direct response. 56.51. What is the average ATMs(per 100,000 adults) in Trinidad and Tobago per year?
Provide a succinct answer. 36.09. In the year 2008, what is the difference between the ATMs(per 100,000 adults) in North America and ATMs(per 100,000 adults) in Canada?
Keep it short and to the point. -25.25. In the year 2008, what is the difference between the ATMs(per 100,000 adults) of North America and ATMs(per 100,000 adults) of Hungary?
Your answer should be very brief. 138.27. In the year 2008, what is the difference between the ATMs(per 100,000 adults) in North America and ATMs(per 100,000 adults) in Trinidad and Tobago?
Make the answer very short. 160.77. In the year 2008, what is the difference between the ATMs(per 100,000 adults) in Canada and ATMs(per 100,000 adults) in Hungary?
Give a very brief answer. 163.52. In the year 2008, what is the difference between the ATMs(per 100,000 adults) of Canada and ATMs(per 100,000 adults) of Trinidad and Tobago?
Give a very brief answer. 186.02. In the year 2008, what is the difference between the ATMs(per 100,000 adults) of Hungary and ATMs(per 100,000 adults) of Trinidad and Tobago?
Make the answer very short. 22.5. In the year 2009, what is the difference between the ATMs(per 100,000 adults) in North America and ATMs(per 100,000 adults) in Canada?
Your response must be concise. -21.52. In the year 2009, what is the difference between the ATMs(per 100,000 adults) of North America and ATMs(per 100,000 adults) of Hungary?
Make the answer very short. 139.04. In the year 2009, what is the difference between the ATMs(per 100,000 adults) of North America and ATMs(per 100,000 adults) of Trinidad and Tobago?
Ensure brevity in your answer.  160.71. In the year 2009, what is the difference between the ATMs(per 100,000 adults) of Canada and ATMs(per 100,000 adults) of Hungary?
Provide a short and direct response. 160.55. In the year 2009, what is the difference between the ATMs(per 100,000 adults) in Canada and ATMs(per 100,000 adults) in Trinidad and Tobago?
Your response must be concise. 182.22. In the year 2009, what is the difference between the ATMs(per 100,000 adults) in Hungary and ATMs(per 100,000 adults) in Trinidad and Tobago?
Give a very brief answer. 21.67. In the year 2010, what is the difference between the ATMs(per 100,000 adults) of North America and ATMs(per 100,000 adults) of Hungary?
Your answer should be compact. 161.63. In the year 2010, what is the difference between the ATMs(per 100,000 adults) in North America and ATMs(per 100,000 adults) in Trinidad and Tobago?
Your answer should be compact. 183.51. In the year 2010, what is the difference between the ATMs(per 100,000 adults) in Canada and ATMs(per 100,000 adults) in Hungary?
Make the answer very short. 161.63. In the year 2010, what is the difference between the ATMs(per 100,000 adults) in Canada and ATMs(per 100,000 adults) in Trinidad and Tobago?
Offer a very short reply. 183.51. In the year 2010, what is the difference between the ATMs(per 100,000 adults) of Hungary and ATMs(per 100,000 adults) of Trinidad and Tobago?
Give a very brief answer. 21.88. In the year 2011, what is the difference between the ATMs(per 100,000 adults) in North America and ATMs(per 100,000 adults) in Canada?
Make the answer very short. 0. In the year 2011, what is the difference between the ATMs(per 100,000 adults) in North America and ATMs(per 100,000 adults) in Hungary?
Your answer should be compact. 149.94. In the year 2011, what is the difference between the ATMs(per 100,000 adults) of North America and ATMs(per 100,000 adults) of Trinidad and Tobago?
Your answer should be very brief. 172.37. In the year 2011, what is the difference between the ATMs(per 100,000 adults) in Canada and ATMs(per 100,000 adults) in Hungary?
Give a very brief answer. 149.94. In the year 2011, what is the difference between the ATMs(per 100,000 adults) in Canada and ATMs(per 100,000 adults) in Trinidad and Tobago?
Your answer should be compact. 172.37. In the year 2011, what is the difference between the ATMs(per 100,000 adults) of Hungary and ATMs(per 100,000 adults) of Trinidad and Tobago?
Provide a short and direct response. 22.44. In the year 2012, what is the difference between the ATMs(per 100,000 adults) of North America and ATMs(per 100,000 adults) of Hungary?
Ensure brevity in your answer.  146.83. In the year 2012, what is the difference between the ATMs(per 100,000 adults) in North America and ATMs(per 100,000 adults) in Trinidad and Tobago?
Keep it short and to the point. 167.39. In the year 2012, what is the difference between the ATMs(per 100,000 adults) of Canada and ATMs(per 100,000 adults) of Hungary?
Give a very brief answer. 146.83. In the year 2012, what is the difference between the ATMs(per 100,000 adults) in Canada and ATMs(per 100,000 adults) in Trinidad and Tobago?
Your answer should be very brief. 167.39. In the year 2012, what is the difference between the ATMs(per 100,000 adults) of Hungary and ATMs(per 100,000 adults) of Trinidad and Tobago?
Your answer should be very brief. 20.56. In the year 2013, what is the difference between the ATMs(per 100,000 adults) of North America and ATMs(per 100,000 adults) of Canada?
Your answer should be compact. 0. In the year 2013, what is the difference between the ATMs(per 100,000 adults) in North America and ATMs(per 100,000 adults) in Hungary?
Give a very brief answer. 164.04. In the year 2013, what is the difference between the ATMs(per 100,000 adults) in North America and ATMs(per 100,000 adults) in Trinidad and Tobago?
Offer a terse response. 180.79. In the year 2013, what is the difference between the ATMs(per 100,000 adults) of Canada and ATMs(per 100,000 adults) of Hungary?
Your response must be concise. 164.04. In the year 2013, what is the difference between the ATMs(per 100,000 adults) of Canada and ATMs(per 100,000 adults) of Trinidad and Tobago?
Provide a short and direct response. 180.79. In the year 2013, what is the difference between the ATMs(per 100,000 adults) in Hungary and ATMs(per 100,000 adults) in Trinidad and Tobago?
Give a very brief answer. 16.75. In the year 2014, what is the difference between the ATMs(per 100,000 adults) in North America and ATMs(per 100,000 adults) in Hungary?
Offer a terse response. 164.24. In the year 2014, what is the difference between the ATMs(per 100,000 adults) of North America and ATMs(per 100,000 adults) of Trinidad and Tobago?
Your answer should be very brief. 181.43. In the year 2014, what is the difference between the ATMs(per 100,000 adults) in Canada and ATMs(per 100,000 adults) in Hungary?
Your response must be concise. 164.24. In the year 2014, what is the difference between the ATMs(per 100,000 adults) in Canada and ATMs(per 100,000 adults) in Trinidad and Tobago?
Provide a succinct answer. 181.43. In the year 2014, what is the difference between the ATMs(per 100,000 adults) in Hungary and ATMs(per 100,000 adults) in Trinidad and Tobago?
Offer a terse response. 17.2. What is the ratio of the ATMs(per 100,000 adults) in Hungary in 2008 to that in 2009?
Offer a very short reply. 0.97. What is the ratio of the ATMs(per 100,000 adults) of Trinidad and Tobago in 2008 to that in 2009?
Ensure brevity in your answer.  0.93. What is the ratio of the ATMs(per 100,000 adults) of North America in 2008 to that in 2010?
Ensure brevity in your answer.  0.88. What is the ratio of the ATMs(per 100,000 adults) in Canada in 2008 to that in 2010?
Provide a short and direct response. 1. What is the ratio of the ATMs(per 100,000 adults) in Hungary in 2008 to that in 2010?
Your answer should be very brief. 0.96. What is the ratio of the ATMs(per 100,000 adults) in Trinidad and Tobago in 2008 to that in 2010?
Provide a short and direct response. 0.91. What is the ratio of the ATMs(per 100,000 adults) of North America in 2008 to that in 2011?
Offer a very short reply. 0.93. What is the ratio of the ATMs(per 100,000 adults) in Canada in 2008 to that in 2011?
Offer a very short reply. 1.05. What is the ratio of the ATMs(per 100,000 adults) of Hungary in 2008 to that in 2011?
Make the answer very short. 0.94. What is the ratio of the ATMs(per 100,000 adults) in Trinidad and Tobago in 2008 to that in 2011?
Provide a succinct answer. 0.9. What is the ratio of the ATMs(per 100,000 adults) of North America in 2008 to that in 2012?
Provide a short and direct response. 0.95. What is the ratio of the ATMs(per 100,000 adults) of Canada in 2008 to that in 2012?
Provide a short and direct response. 1.07. What is the ratio of the ATMs(per 100,000 adults) in Hungary in 2008 to that in 2012?
Make the answer very short. 0.96. What is the ratio of the ATMs(per 100,000 adults) of Trinidad and Tobago in 2008 to that in 2012?
Your answer should be very brief. 0.88. What is the ratio of the ATMs(per 100,000 adults) of North America in 2008 to that in 2013?
Give a very brief answer. 0.87. What is the ratio of the ATMs(per 100,000 adults) in Canada in 2008 to that in 2013?
Offer a very short reply. 0.98. What is the ratio of the ATMs(per 100,000 adults) of Hungary in 2008 to that in 2013?
Keep it short and to the point. 0.95. What is the ratio of the ATMs(per 100,000 adults) in Trinidad and Tobago in 2008 to that in 2013?
Offer a very short reply. 0.78. What is the ratio of the ATMs(per 100,000 adults) in North America in 2008 to that in 2014?
Your answer should be compact. 0.87. What is the ratio of the ATMs(per 100,000 adults) of Canada in 2008 to that in 2014?
Ensure brevity in your answer.  0.98. What is the ratio of the ATMs(per 100,000 adults) in Hungary in 2008 to that in 2014?
Keep it short and to the point. 0.93. What is the ratio of the ATMs(per 100,000 adults) in Trinidad and Tobago in 2008 to that in 2014?
Offer a terse response. 0.77. What is the ratio of the ATMs(per 100,000 adults) in North America in 2009 to that in 2010?
Offer a terse response. 0.89. What is the ratio of the ATMs(per 100,000 adults) of Canada in 2009 to that in 2010?
Your answer should be compact. 0.99. What is the ratio of the ATMs(per 100,000 adults) in Hungary in 2009 to that in 2010?
Offer a very short reply. 0.98. What is the ratio of the ATMs(per 100,000 adults) in Trinidad and Tobago in 2009 to that in 2010?
Your response must be concise. 0.98. What is the ratio of the ATMs(per 100,000 adults) in North America in 2009 to that in 2011?
Give a very brief answer. 0.94. What is the ratio of the ATMs(per 100,000 adults) in Canada in 2009 to that in 2011?
Your answer should be compact. 1.04. What is the ratio of the ATMs(per 100,000 adults) in Hungary in 2009 to that in 2011?
Give a very brief answer. 0.96. What is the ratio of the ATMs(per 100,000 adults) in Trinidad and Tobago in 2009 to that in 2011?
Offer a terse response. 0.96. What is the ratio of the ATMs(per 100,000 adults) of North America in 2009 to that in 2012?
Your answer should be very brief. 0.96. What is the ratio of the ATMs(per 100,000 adults) in Canada in 2009 to that in 2012?
Your response must be concise. 1.06. What is the ratio of the ATMs(per 100,000 adults) in Hungary in 2009 to that in 2012?
Your answer should be very brief. 0.98. What is the ratio of the ATMs(per 100,000 adults) of Trinidad and Tobago in 2009 to that in 2012?
Your response must be concise. 0.94. What is the ratio of the ATMs(per 100,000 adults) of North America in 2009 to that in 2013?
Make the answer very short. 0.88. What is the ratio of the ATMs(per 100,000 adults) of Canada in 2009 to that in 2013?
Your response must be concise. 0.98. What is the ratio of the ATMs(per 100,000 adults) of Trinidad and Tobago in 2009 to that in 2013?
Your answer should be compact. 0.84. What is the ratio of the ATMs(per 100,000 adults) of North America in 2009 to that in 2014?
Your response must be concise. 0.88. What is the ratio of the ATMs(per 100,000 adults) of Canada in 2009 to that in 2014?
Keep it short and to the point. 0.97. What is the ratio of the ATMs(per 100,000 adults) of Hungary in 2009 to that in 2014?
Provide a short and direct response. 0.96. What is the ratio of the ATMs(per 100,000 adults) in Trinidad and Tobago in 2009 to that in 2014?
Offer a terse response. 0.83. What is the ratio of the ATMs(per 100,000 adults) in North America in 2010 to that in 2011?
Your response must be concise. 1.05. What is the ratio of the ATMs(per 100,000 adults) in Canada in 2010 to that in 2011?
Ensure brevity in your answer.  1.05. What is the ratio of the ATMs(per 100,000 adults) in Hungary in 2010 to that in 2011?
Give a very brief answer. 0.98. What is the ratio of the ATMs(per 100,000 adults) in Trinidad and Tobago in 2010 to that in 2011?
Provide a succinct answer. 0.99. What is the ratio of the ATMs(per 100,000 adults) of North America in 2010 to that in 2012?
Your answer should be compact. 1.07. What is the ratio of the ATMs(per 100,000 adults) of Canada in 2010 to that in 2012?
Ensure brevity in your answer.  1.07. What is the ratio of the ATMs(per 100,000 adults) in Hungary in 2010 to that in 2012?
Offer a terse response. 1. What is the ratio of the ATMs(per 100,000 adults) in Trinidad and Tobago in 2010 to that in 2012?
Your answer should be compact. 0.96. What is the ratio of the ATMs(per 100,000 adults) in North America in 2010 to that in 2013?
Provide a short and direct response. 0.99. What is the ratio of the ATMs(per 100,000 adults) in Canada in 2010 to that in 2013?
Ensure brevity in your answer.  0.99. What is the ratio of the ATMs(per 100,000 adults) in Hungary in 2010 to that in 2013?
Your response must be concise. 0.99. What is the ratio of the ATMs(per 100,000 adults) in Trinidad and Tobago in 2010 to that in 2013?
Make the answer very short. 0.86. What is the ratio of the ATMs(per 100,000 adults) in North America in 2010 to that in 2014?
Provide a short and direct response. 0.98. What is the ratio of the ATMs(per 100,000 adults) in Canada in 2010 to that in 2014?
Offer a very short reply. 0.98. What is the ratio of the ATMs(per 100,000 adults) in Hungary in 2010 to that in 2014?
Ensure brevity in your answer.  0.97. What is the ratio of the ATMs(per 100,000 adults) of Trinidad and Tobago in 2010 to that in 2014?
Give a very brief answer. 0.85. What is the ratio of the ATMs(per 100,000 adults) of North America in 2011 to that in 2012?
Provide a succinct answer. 1.02. What is the ratio of the ATMs(per 100,000 adults) in Canada in 2011 to that in 2012?
Your response must be concise. 1.02. What is the ratio of the ATMs(per 100,000 adults) of Hungary in 2011 to that in 2012?
Ensure brevity in your answer.  1.02. What is the ratio of the ATMs(per 100,000 adults) of Trinidad and Tobago in 2011 to that in 2012?
Ensure brevity in your answer.  0.98. What is the ratio of the ATMs(per 100,000 adults) of North America in 2011 to that in 2013?
Your answer should be very brief. 0.94. What is the ratio of the ATMs(per 100,000 adults) in Canada in 2011 to that in 2013?
Make the answer very short. 0.94. What is the ratio of the ATMs(per 100,000 adults) of Trinidad and Tobago in 2011 to that in 2013?
Offer a very short reply. 0.87. What is the ratio of the ATMs(per 100,000 adults) in North America in 2011 to that in 2014?
Provide a short and direct response. 0.93. What is the ratio of the ATMs(per 100,000 adults) in Canada in 2011 to that in 2014?
Offer a terse response. 0.93. What is the ratio of the ATMs(per 100,000 adults) in Hungary in 2011 to that in 2014?
Make the answer very short. 0.99. What is the ratio of the ATMs(per 100,000 adults) in Trinidad and Tobago in 2011 to that in 2014?
Provide a succinct answer. 0.86. What is the ratio of the ATMs(per 100,000 adults) of North America in 2012 to that in 2013?
Provide a succinct answer. 0.92. What is the ratio of the ATMs(per 100,000 adults) of Canada in 2012 to that in 2013?
Keep it short and to the point. 0.92. What is the ratio of the ATMs(per 100,000 adults) of Hungary in 2012 to that in 2013?
Ensure brevity in your answer.  0.99. What is the ratio of the ATMs(per 100,000 adults) in Trinidad and Tobago in 2012 to that in 2013?
Your answer should be compact. 0.89. What is the ratio of the ATMs(per 100,000 adults) in North America in 2012 to that in 2014?
Provide a short and direct response. 0.91. What is the ratio of the ATMs(per 100,000 adults) in Canada in 2012 to that in 2014?
Ensure brevity in your answer.  0.91. What is the ratio of the ATMs(per 100,000 adults) in Hungary in 2012 to that in 2014?
Ensure brevity in your answer.  0.97. What is the ratio of the ATMs(per 100,000 adults) in Trinidad and Tobago in 2012 to that in 2014?
Your answer should be compact. 0.88. What is the ratio of the ATMs(per 100,000 adults) of Canada in 2013 to that in 2014?
Offer a terse response. 1. What is the ratio of the ATMs(per 100,000 adults) of Hungary in 2013 to that in 2014?
Keep it short and to the point. 0.99. What is the difference between the highest and the second highest ATMs(per 100,000 adults) in Canada?
Keep it short and to the point. 1.01. What is the difference between the highest and the second highest ATMs(per 100,000 adults) of Hungary?
Provide a short and direct response. 0.41. What is the difference between the highest and the second highest ATMs(per 100,000 adults) in Trinidad and Tobago?
Provide a succinct answer. 0.38. What is the difference between the highest and the lowest ATMs(per 100,000 adults) in North America?
Make the answer very short. 29.9. What is the difference between the highest and the lowest ATMs(per 100,000 adults) in Canada?
Ensure brevity in your answer.  18.95. What is the difference between the highest and the lowest ATMs(per 100,000 adults) of Hungary?
Offer a terse response. 3.93. What is the difference between the highest and the lowest ATMs(per 100,000 adults) of Trinidad and Tobago?
Keep it short and to the point. 9.24. 